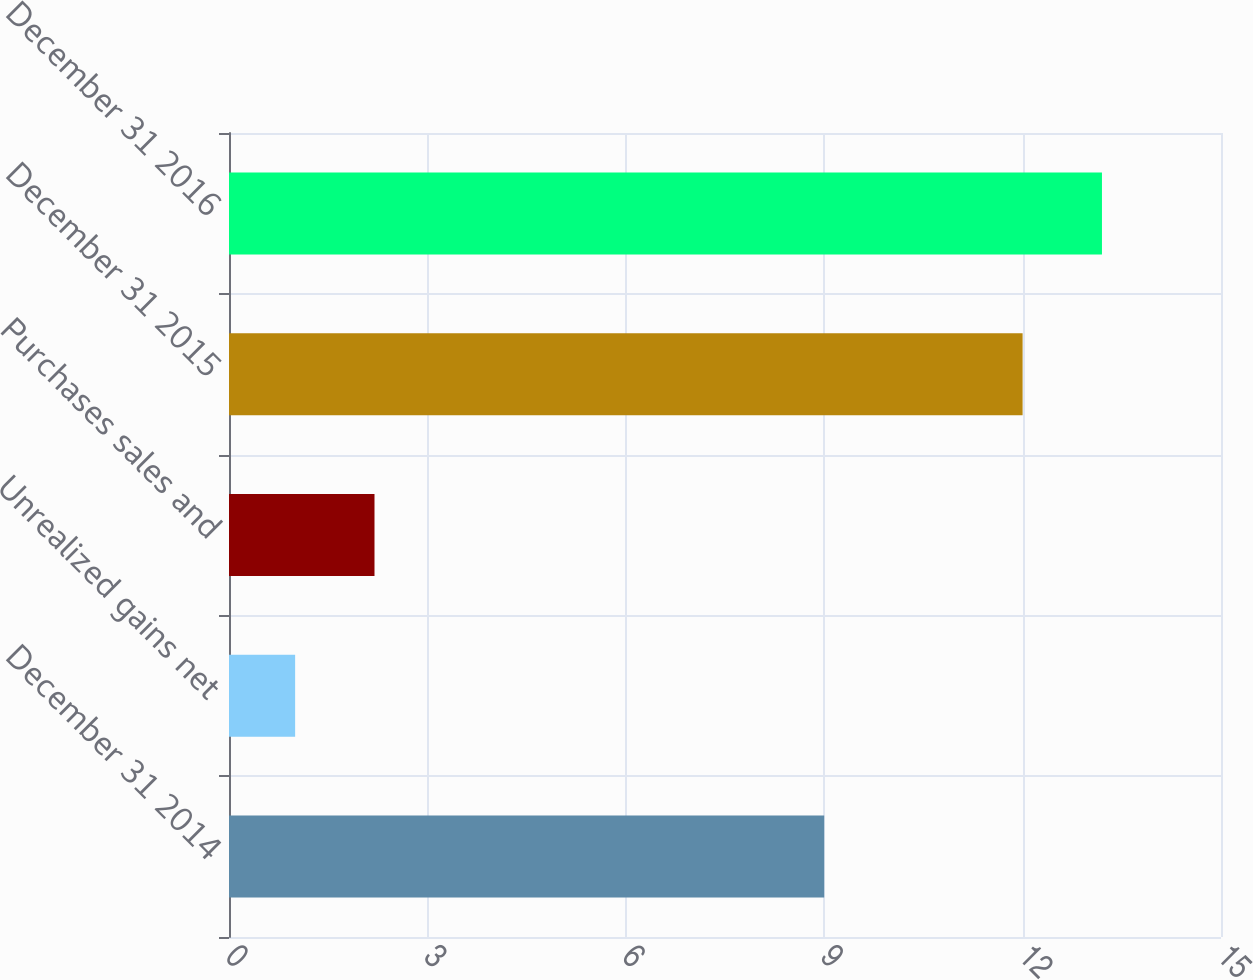<chart> <loc_0><loc_0><loc_500><loc_500><bar_chart><fcel>December 31 2014<fcel>Unrealized gains net<fcel>Purchases sales and<fcel>December 31 2015<fcel>December 31 2016<nl><fcel>9<fcel>1<fcel>2.2<fcel>12<fcel>13.2<nl></chart> 